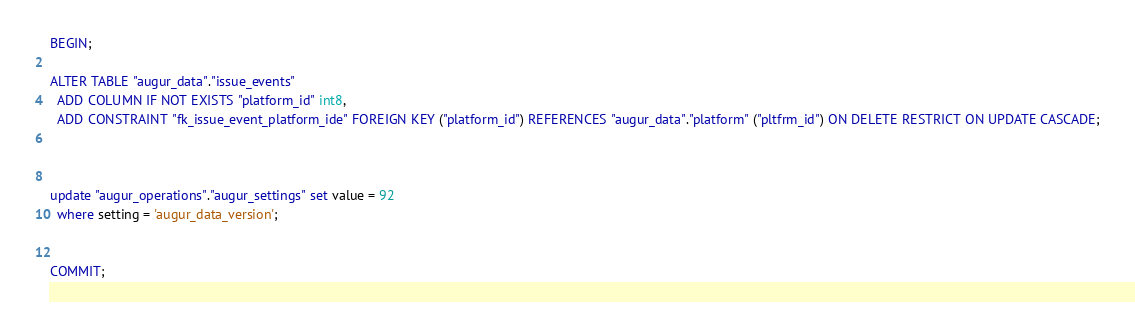Convert code to text. <code><loc_0><loc_0><loc_500><loc_500><_SQL_>BEGIN; 

ALTER TABLE "augur_data"."issue_events" 
  ADD COLUMN IF NOT EXISTS "platform_id" int8,
  ADD CONSTRAINT "fk_issue_event_platform_ide" FOREIGN KEY ("platform_id") REFERENCES "augur_data"."platform" ("pltfrm_id") ON DELETE RESTRICT ON UPDATE CASCADE;



update "augur_operations"."augur_settings" set value = 92 
  where setting = 'augur_data_version'; 


COMMIT; </code> 